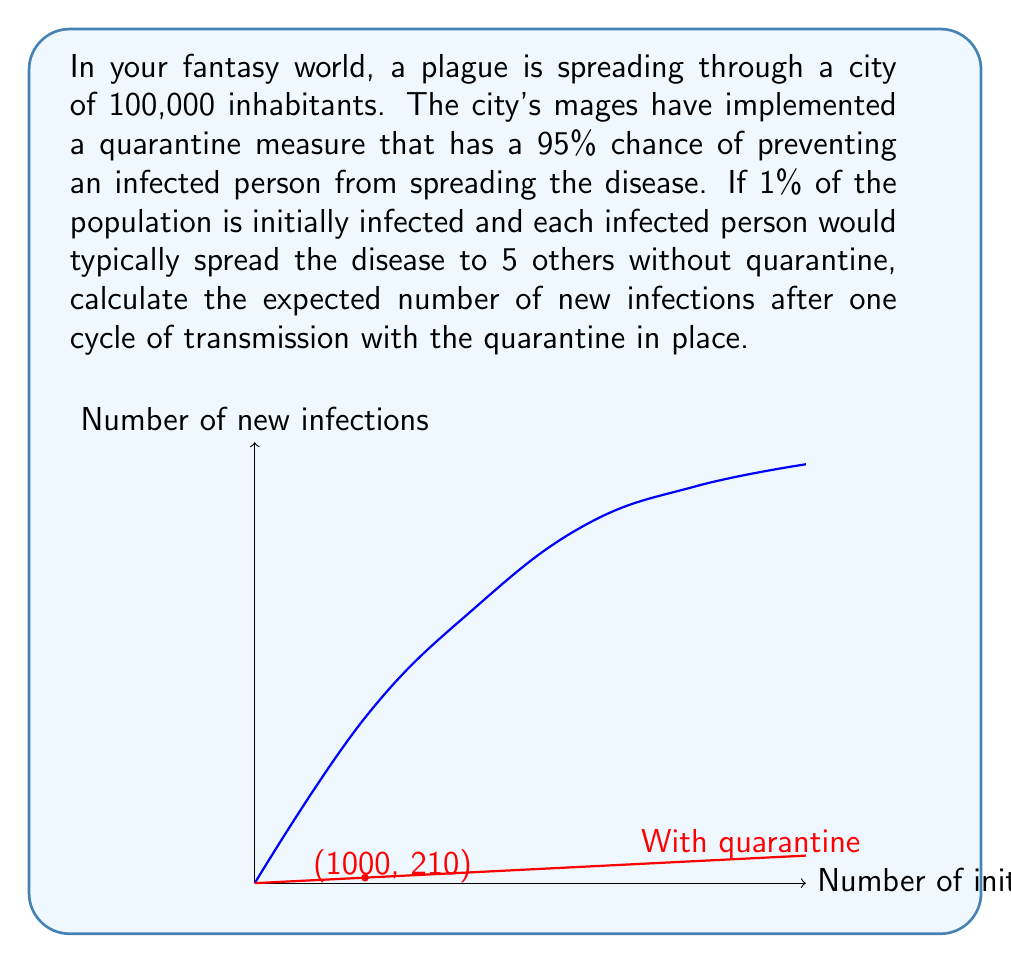Can you solve this math problem? Let's approach this step-by-step:

1) First, let's identify the key information:
   - Total population: 100,000
   - Initially infected: 1% = 1,000 people
   - Quarantine effectiveness: 95%
   - Infection rate without quarantine: 5 new infections per infected person

2) Without quarantine, the expected number of new infections would be:
   $$1000 \times 5 = 5000$$

3) However, the quarantine is 95% effective. This means that only 5% of the potential infections will occur. We can calculate this as:
   $$5000 \times (1 - 0.95) = 5000 \times 0.05 = 250$$

4) Therefore, the expected number of new infections with the quarantine in place is 250.

5) We can verify this using probability theory:
   - Each infected person has a 5% chance of infecting each of 5 people.
   - The expected number of new infections per infected person is:
     $$5 \times 0.05 = 0.25$$
   - With 1000 initially infected people, the total expected new infections is:
     $$1000 \times 0.25 = 250$$

This aligns with our previous calculation.
Answer: 250 new infections 